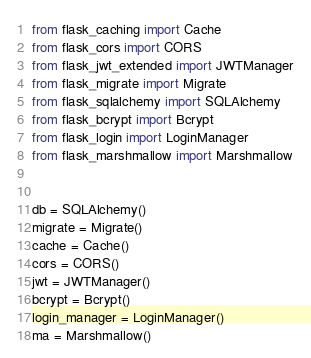<code> <loc_0><loc_0><loc_500><loc_500><_Python_>from flask_caching import Cache
from flask_cors import CORS
from flask_jwt_extended import JWTManager
from flask_migrate import Migrate
from flask_sqlalchemy import SQLAlchemy
from flask_bcrypt import Bcrypt
from flask_login import LoginManager
from flask_marshmallow import Marshmallow


db = SQLAlchemy()
migrate = Migrate()
cache = Cache()
cors = CORS()
jwt = JWTManager()
bcrypt = Bcrypt()
login_manager = LoginManager()
ma = Marshmallow()</code> 